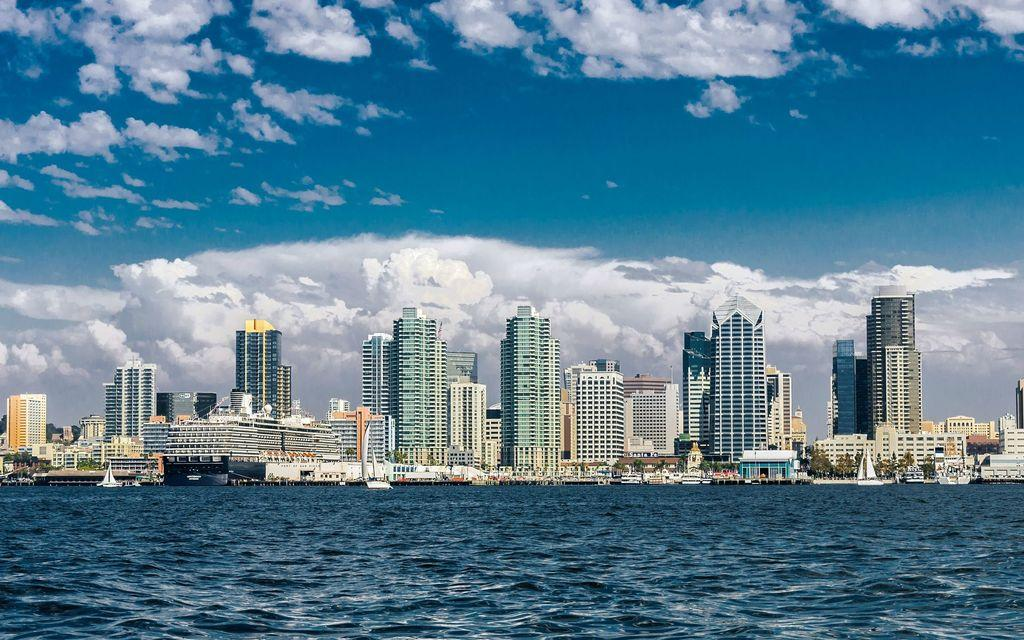What is happening on the surface of the water in the image? There are boats sailing on the surface of the water in the image. What can be seen in the background of the image? There are trees and buildings in the background of the image. What is visible at the top of the image? The sky is visible at the top of the image. What can be observed in the sky? There are clouds in the sky. Where is the unit located in the image? There is no unit present in the image. Is anyone wearing a mask in the image? There is no one wearing a mask in the image. 